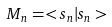<formula> <loc_0><loc_0><loc_500><loc_500>M _ { n } = < { s } _ { n } | { s } _ { n } ></formula> 